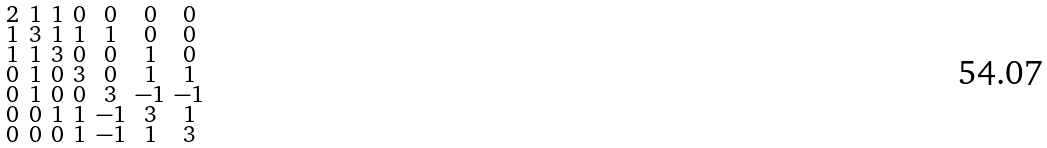Convert formula to latex. <formula><loc_0><loc_0><loc_500><loc_500>\begin{smallmatrix} 2 & 1 & 1 & 0 & 0 & 0 & 0 \\ 1 & 3 & 1 & 1 & 1 & 0 & 0 \\ 1 & 1 & 3 & 0 & 0 & 1 & 0 \\ 0 & 1 & 0 & 3 & 0 & 1 & 1 \\ 0 & 1 & 0 & 0 & 3 & - 1 & - 1 \\ 0 & 0 & 1 & 1 & - 1 & 3 & 1 \\ 0 & 0 & 0 & 1 & - 1 & 1 & 3 \end{smallmatrix}</formula> 